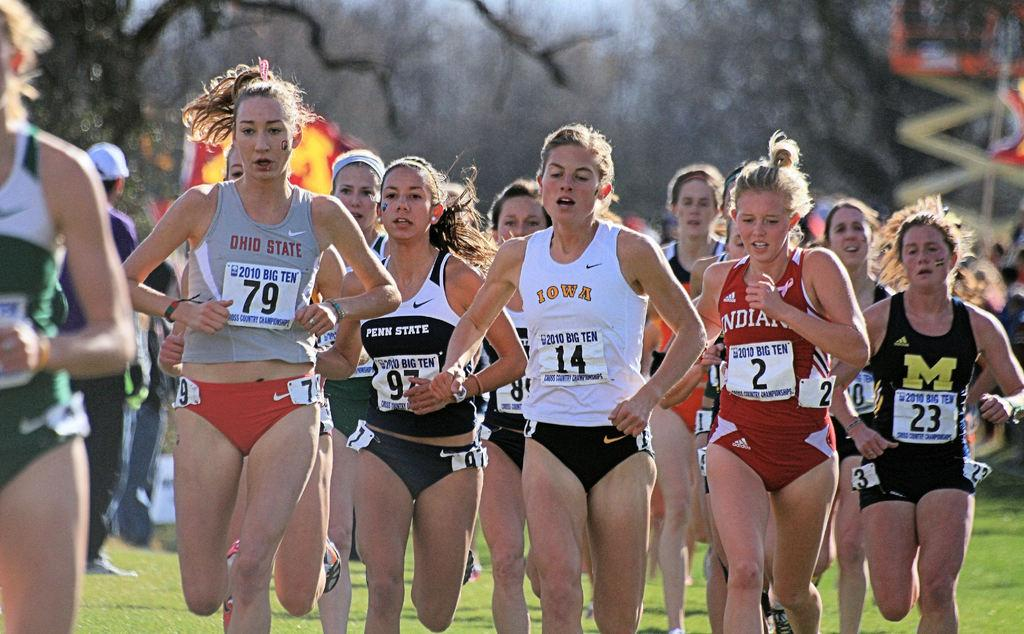What is the main subject of the image? The main subject of the image is a group of girls. What are the girls doing in the image? The girls are running on the ground. Can you describe any additional details about the girls' attire? The girls are wearing badges on their dresses. What can be seen in the background of the image? There are trees in the background of the image. How much weight can the maid lift in the image? There is no maid present in the image, so it is not possible to determine how much weight they might be able to lift. 